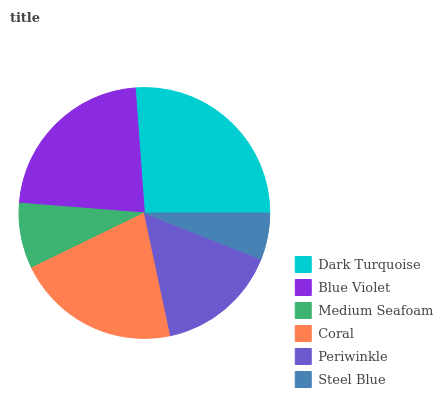Is Steel Blue the minimum?
Answer yes or no. Yes. Is Dark Turquoise the maximum?
Answer yes or no. Yes. Is Blue Violet the minimum?
Answer yes or no. No. Is Blue Violet the maximum?
Answer yes or no. No. Is Dark Turquoise greater than Blue Violet?
Answer yes or no. Yes. Is Blue Violet less than Dark Turquoise?
Answer yes or no. Yes. Is Blue Violet greater than Dark Turquoise?
Answer yes or no. No. Is Dark Turquoise less than Blue Violet?
Answer yes or no. No. Is Coral the high median?
Answer yes or no. Yes. Is Periwinkle the low median?
Answer yes or no. Yes. Is Medium Seafoam the high median?
Answer yes or no. No. Is Medium Seafoam the low median?
Answer yes or no. No. 